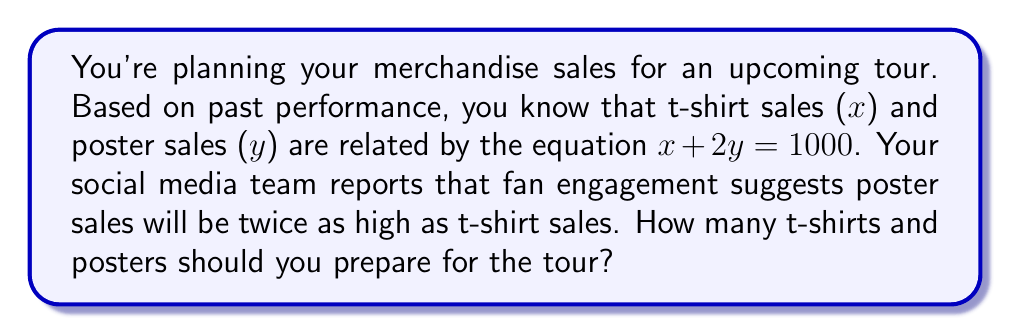Help me with this question. Let's approach this step-by-step:

1) We have two equations to work with:
   
   Equation 1: $x + 2y = 1000$ (based on past performance)
   Equation 2: $y = 2x$ (based on fan engagement prediction)

2) We can solve this system of equations by substitution. Let's substitute Equation 2 into Equation 1:

   $x + 2(2x) = 1000$

3) Simplify:
   
   $x + 4x = 1000$
   $5x = 1000$

4) Solve for x:
   
   $x = 1000 \div 5 = 200$

5) Now that we know x (t-shirt sales), we can find y (poster sales) using Equation 2:

   $y = 2x = 2(200) = 400$

Therefore, you should prepare 200 t-shirts and 400 posters for the tour.
Answer: 200 t-shirts, 400 posters 